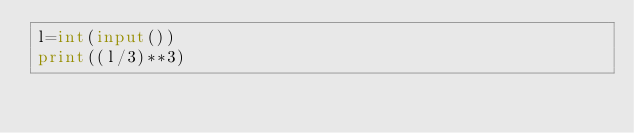Convert code to text. <code><loc_0><loc_0><loc_500><loc_500><_Python_>l=int(input())
print((l/3)**3)</code> 